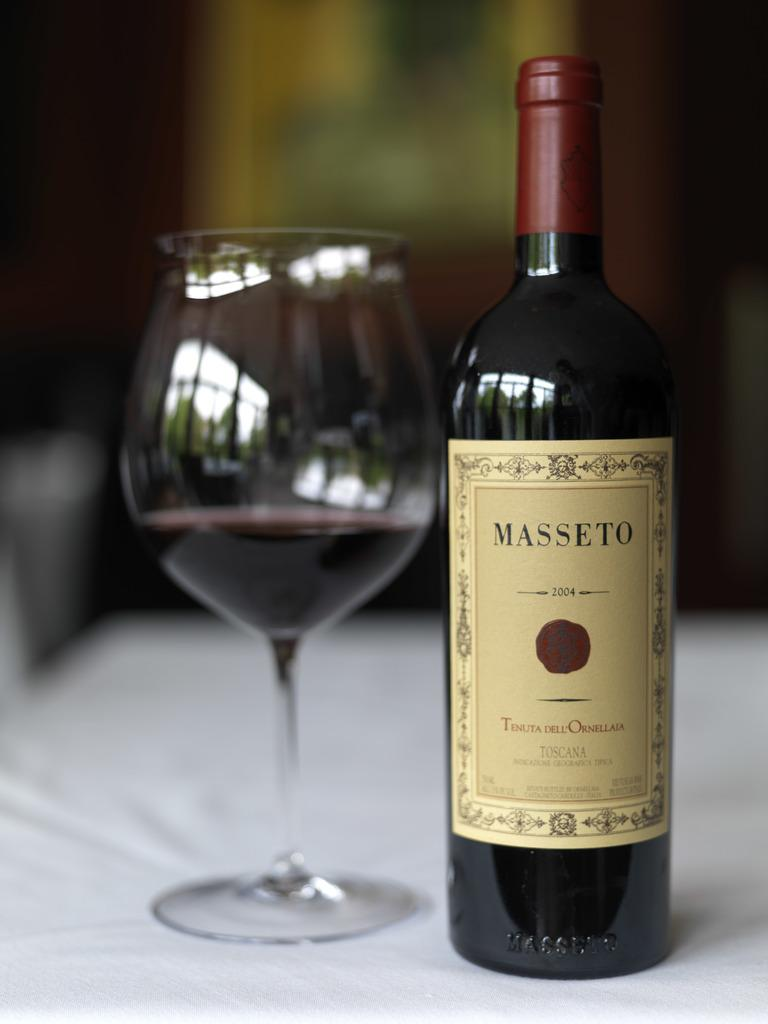<image>
Share a concise interpretation of the image provided. A bottle of wine labelled Masseto next to a glass. 